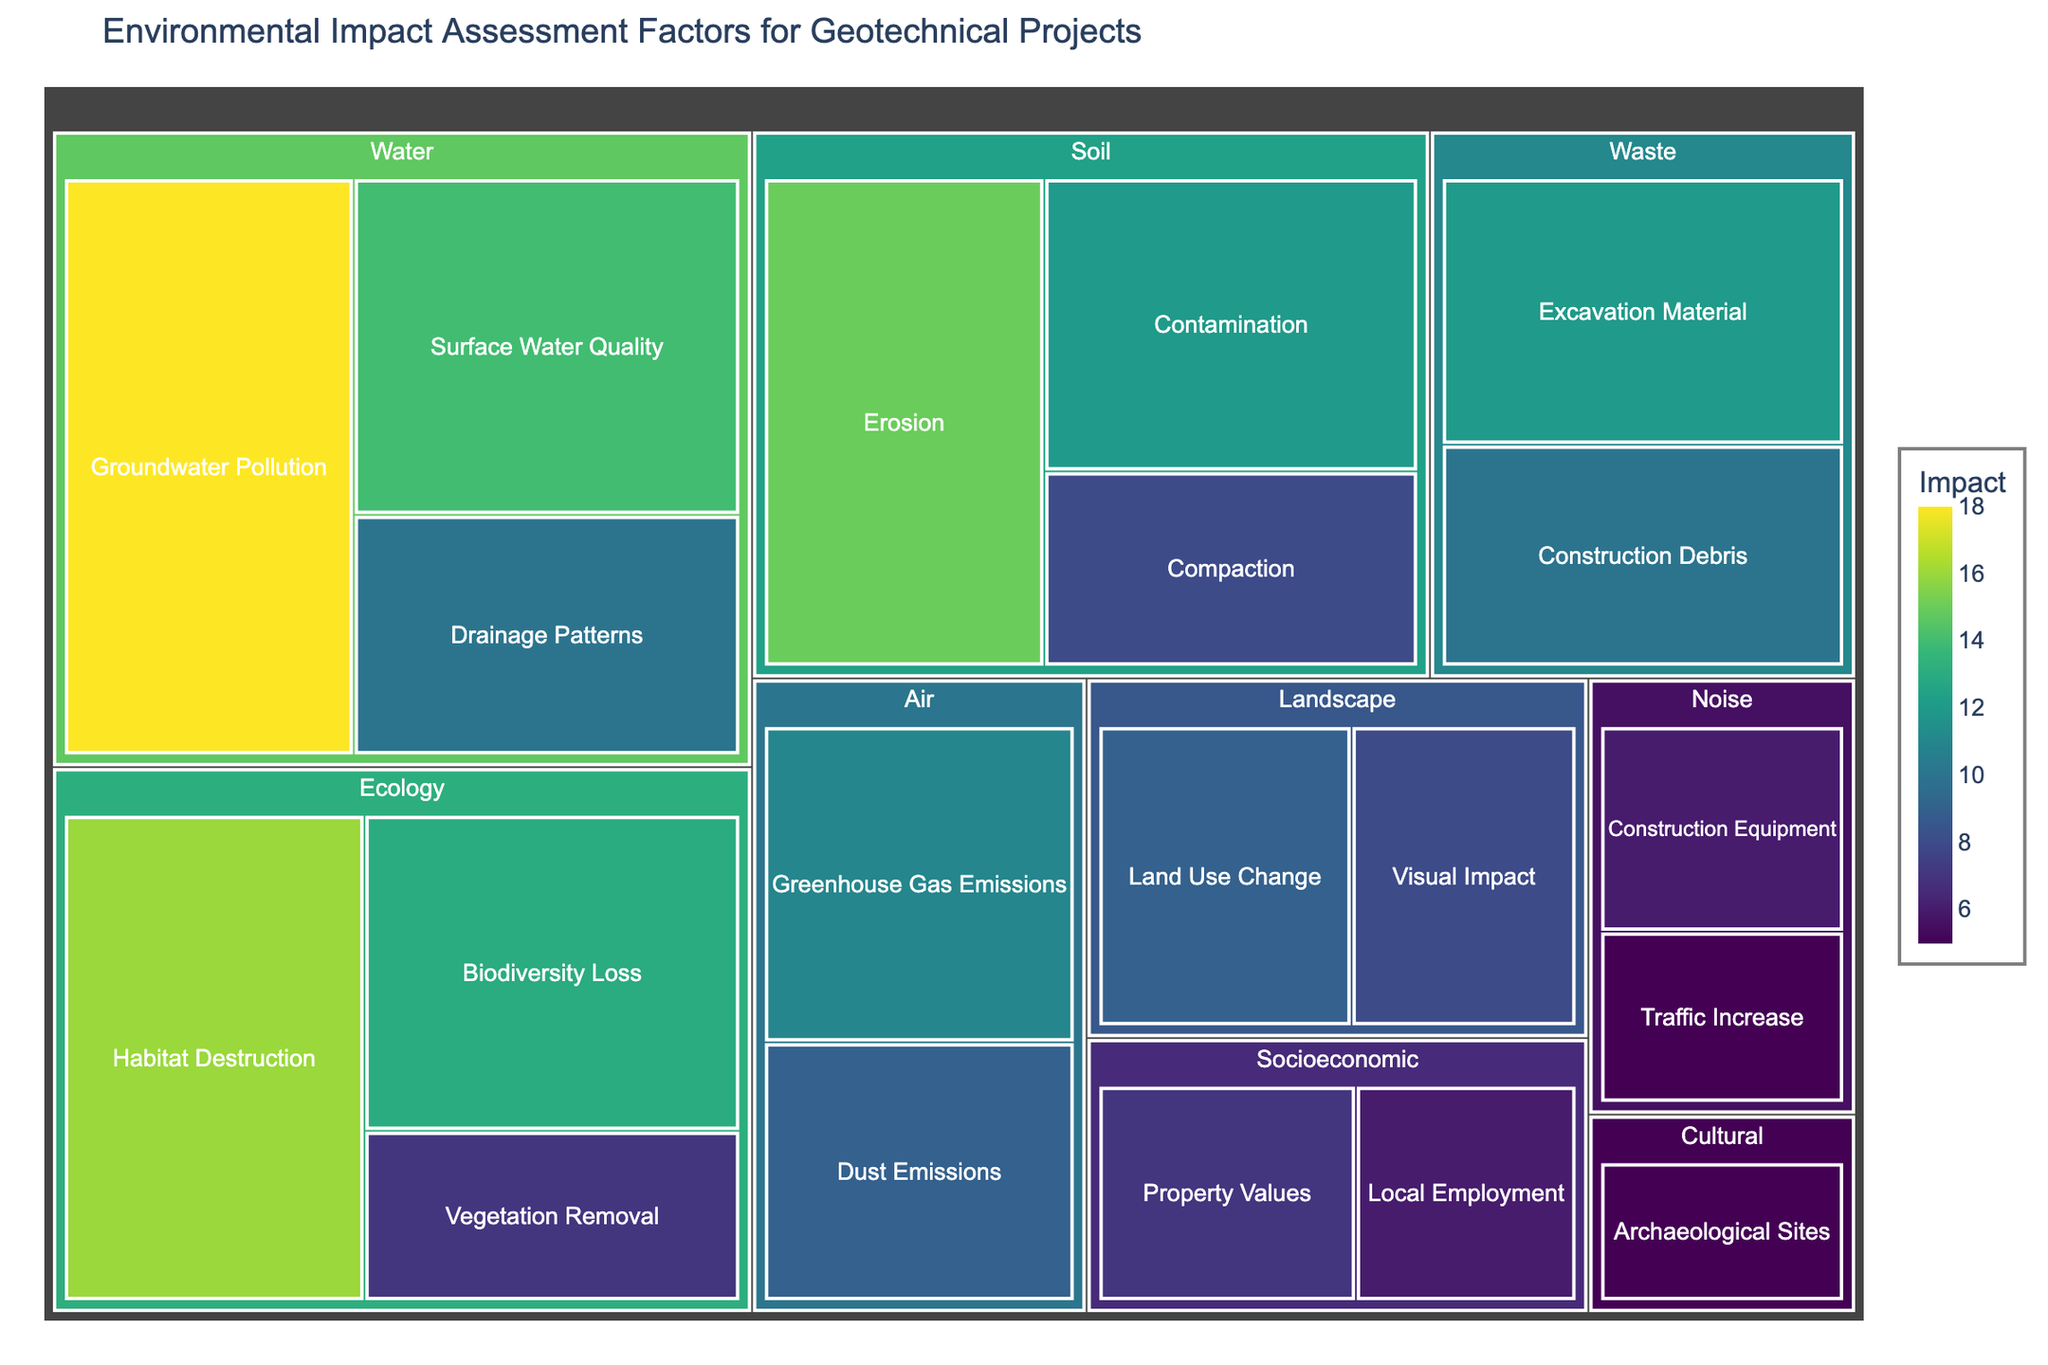What is the title of the figure? The title of the figure is usually placed at the top in a larger and bold font to indicate the overall topic. The title here is "Environmental Impact Assessment Factors for Geotechnical Projects" because it summarizes the content visually represented.
Answer: Environmental Impact Assessment Factors for Geotechnical Projects Which subcategory under the "Water" category has the highest impact? In the "Water" category, we need to look at the subcategories and compare their impact values. The subcategory "Groundwater Pollution" has the highest impact with a value of 18.
Answer: Groundwater Pollution What is the total impact of the "Soil" category? To find the total impact for the "Soil" category, we sum the impact values of all its subcategories: Erosion (15) + Contamination (12) + Compaction (8). Thus, the total impact is 15 + 12 + 8 = 35.
Answer: 35 Which category has the lowest total impact? By summing the impact of the subcategories for each main category and comparing the totals, we find that the "Cultural" category with an impact of 5 (only one subcategory) has the lowest total impact among all categories.
Answer: Cultural Between "Dust Emissions" and "Vegetation Removal," which has a higher impact? By looking at the impact values, "Dust Emissions" under the "Air" category has an impact of 9, while "Vegetation Removal" under the "Ecology" category has an impact of 7. Therefore, "Dust Emissions" has a higher impact.
Answer: Dust Emissions What is the average impact of subcategories under the "Ecology" category? To find the average impact, sum all impacts in the "Ecology" category: Habitat Destruction (16) + Biodiversity Loss (13) + Vegetation Removal (7), and then divide by the number of subcategories: (16 + 13 + 7) / 3 = 36 / 3 = 12.
Answer: 12 How does the impact of "Construction Debris" compare to "Archaeological Sites"? Comparing the two impacts, "Construction Debris" under the "Waste" category has an impact of 10, while "Archaeological Sites" under the "Cultural" category has an impact of 5. Thus, "Construction Debris" has a higher impact.
Answer: Construction Debris Which category has the most subcategories, and how many are there? By counting the subcategories for each category, we see that the "Ecology" category has the most subcategories with a total of 3: Habitat Destruction, Biodiversity Loss, and Vegetation Removal.
Answer: Ecology, 3 What is the combined impact of "Air" and "Noise" categories? To find the combined impact, sum the values from both categories. "Air": Dust Emissions (9) + Greenhouse Gas Emissions (11) = 20. "Noise": Construction Equipment (6) + Traffic Increase (5) = 11. Now, 20 + 11 = 31.
Answer: 31 